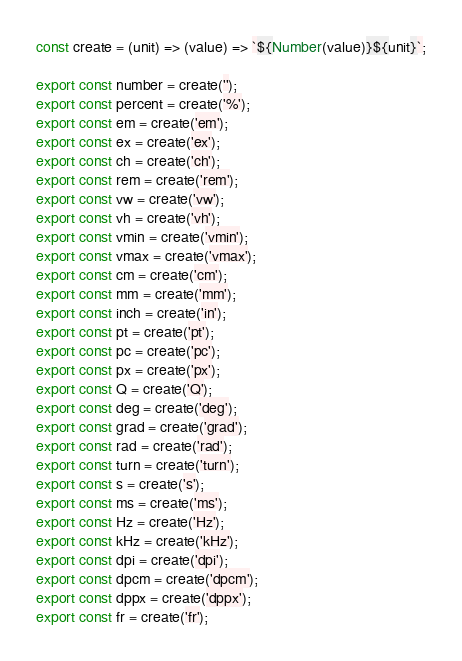Convert code to text. <code><loc_0><loc_0><loc_500><loc_500><_JavaScript_>const create = (unit) => (value) => `${Number(value)}${unit}`;

export const number = create('');
export const percent = create('%');
export const em = create('em');
export const ex = create('ex');
export const ch = create('ch');
export const rem = create('rem');
export const vw = create('vw');
export const vh = create('vh');
export const vmin = create('vmin');
export const vmax = create('vmax');
export const cm = create('cm');
export const mm = create('mm');
export const inch = create('in');
export const pt = create('pt');
export const pc = create('pc');
export const px = create('px');
export const Q = create('Q');
export const deg = create('deg');
export const grad = create('grad');
export const rad = create('rad');
export const turn = create('turn');
export const s = create('s');
export const ms = create('ms');
export const Hz = create('Hz');
export const kHz = create('kHz');
export const dpi = create('dpi');
export const dpcm = create('dpcm');
export const dppx = create('dppx');
export const fr = create('fr');
</code> 